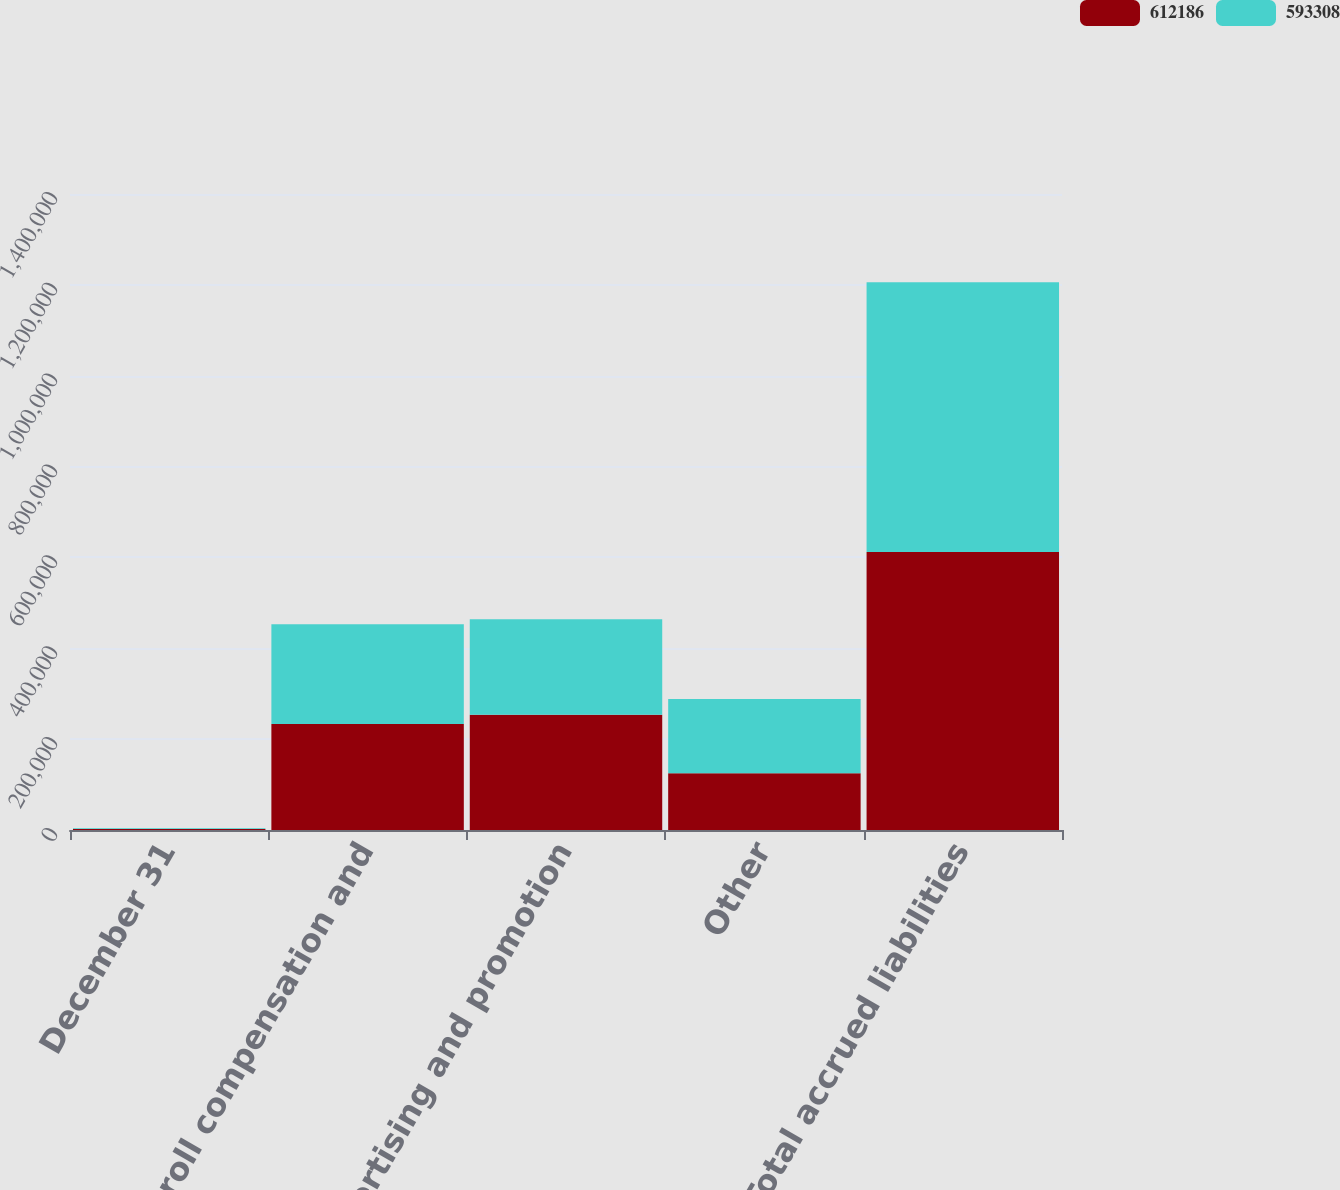<chart> <loc_0><loc_0><loc_500><loc_500><stacked_bar_chart><ecel><fcel>December 31<fcel>Payroll compensation and<fcel>Advertising and promotion<fcel>Other<fcel>Total accrued liabilities<nl><fcel>612186<fcel>2011<fcel>233547<fcel>253534<fcel>125105<fcel>612186<nl><fcel>593308<fcel>2010<fcel>219353<fcel>210543<fcel>163412<fcel>593308<nl></chart> 